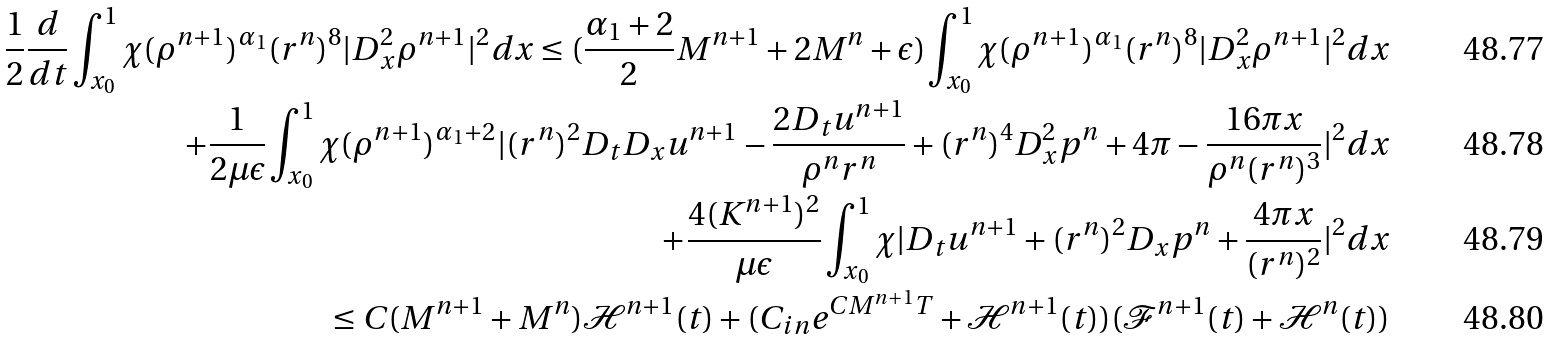Convert formula to latex. <formula><loc_0><loc_0><loc_500><loc_500>\frac { 1 } { 2 } \frac { d } { d t } \int _ { x _ { 0 } } ^ { 1 } \chi ( \rho ^ { n + 1 } ) ^ { \alpha _ { 1 } } ( r ^ { n } ) ^ { 8 } | D _ { x } ^ { 2 } \rho ^ { n + 1 } | ^ { 2 } d x \leq ( \frac { \alpha _ { 1 } + 2 } { 2 } M ^ { n + 1 } + 2 M ^ { n } + \epsilon ) \int _ { x _ { 0 } } ^ { 1 } \chi ( \rho ^ { n + 1 } ) ^ { \alpha _ { 1 } } ( r ^ { n } ) ^ { 8 } | D _ { x } ^ { 2 } \rho ^ { n + 1 } | ^ { 2 } d x \\ + \frac { 1 } { 2 \mu \epsilon } \int _ { x _ { 0 } } ^ { 1 } \chi ( \rho ^ { n + 1 } ) ^ { \alpha _ { 1 } + 2 } | ( r ^ { n } ) ^ { 2 } D _ { t } D _ { x } u ^ { n + 1 } - \frac { 2 D _ { t } u ^ { n + 1 } } { \rho ^ { n } r ^ { n } } + ( r ^ { n } ) ^ { 4 } D _ { x } ^ { 2 } p ^ { n } + 4 \pi - \frac { 1 6 \pi x } { \rho ^ { n } ( r ^ { n } ) ^ { 3 } } | ^ { 2 } d x \\ + \frac { 4 ( K ^ { n + 1 } ) ^ { 2 } } { \mu \epsilon } \int _ { x _ { 0 } } ^ { 1 } \chi | D _ { t } u ^ { n + 1 } + ( r ^ { n } ) ^ { 2 } D _ { x } p ^ { n } + \frac { 4 \pi x } { ( r ^ { n } ) ^ { 2 } } | ^ { 2 } d x \\ \leq C ( M ^ { n + 1 } + M ^ { n } ) \mathcal { H } ^ { n + 1 } ( t ) + ( C _ { i n } e ^ { C M ^ { n + 1 } T } + \mathcal { H } ^ { n + 1 } ( t ) ) ( \mathcal { F } ^ { n + 1 } ( t ) + \mathcal { H } ^ { n } ( t ) )</formula> 